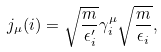Convert formula to latex. <formula><loc_0><loc_0><loc_500><loc_500>j _ { \mu } ( i ) = \sqrt { \frac { m } { \epsilon ^ { \prime } _ { i } } } \gamma _ { i } ^ { \mu } \sqrt { \frac { m } { \epsilon _ { i } } } ,</formula> 